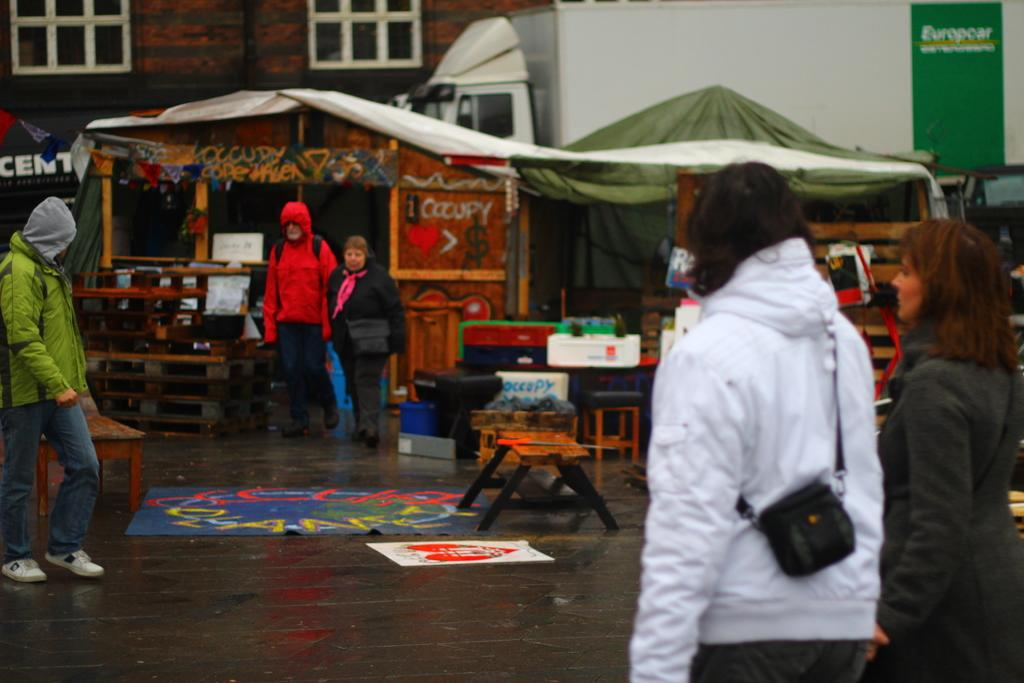Who or what can be seen in the image? There are people in the image. What type of furniture is present in the image? There are stools and tables in the image. What type of temporary shelter is visible in the image? There are tents in the image. What other objects can be seen in the image? There are other objects in the image, but their specific details are not mentioned in the provided facts. What can be seen in the background of the image? There is a building visible in the background of the image. What type of lift is used to transport people in the image? There is no lift present in the image; it features people, stools, tables, tents, and a building in the background. What type of harmony is being played by the people in the image? There is no indication of music or harmony in the image; it only shows people, stools, tables, tents, and a building in the background. 